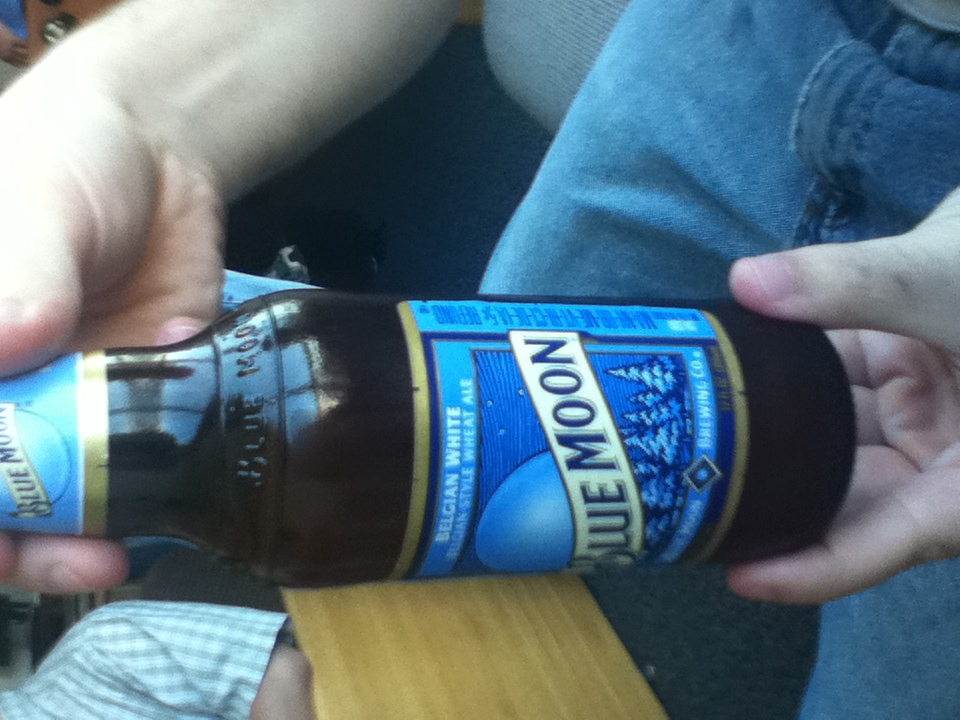Can you suggest a good pairing for this beer? Blue Moon beer pairs wonderfully with seafood dishes like grilled shrimp or light pastas. Its citrus undertones also make it a great complement to orange-flavored desserts or a fresh garden salad. 